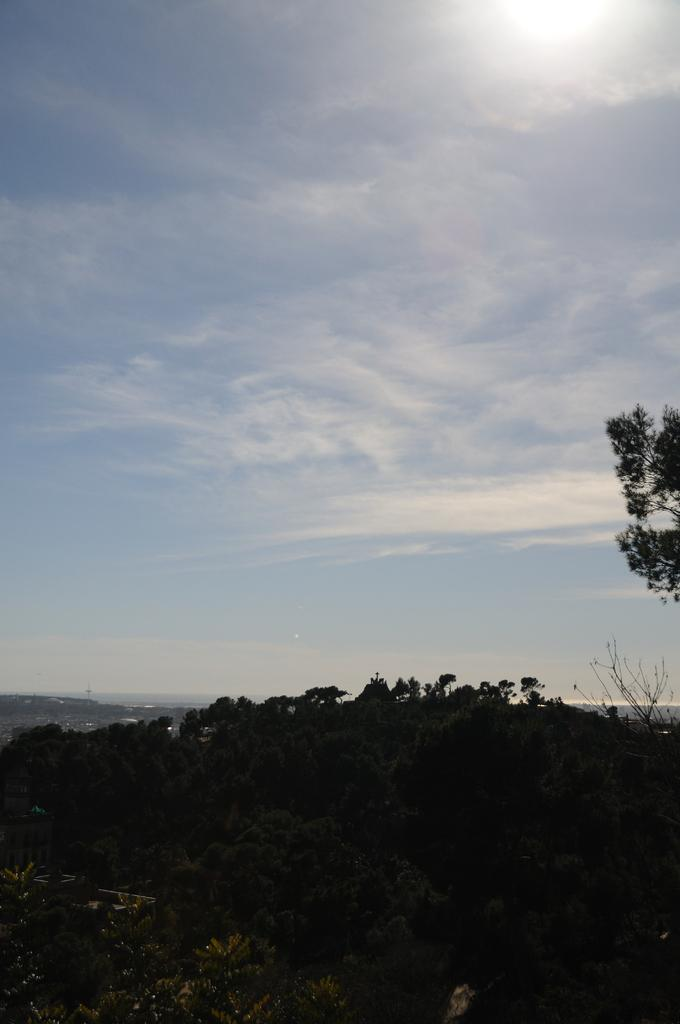What type of living organisms can be seen in the image? There are many plants in the image. What is the color of the sky in the image? The sky is blue in color. What can be seen in the sky besides the blue color? There are clouds visible in the sky. What celestial body is present in the image? The sun is present in the image, or at the top of, the image. What type of kitty can be seen playing with a stranger in the image? There is no kitty or stranger present in the image; it only features plants and the sky. 